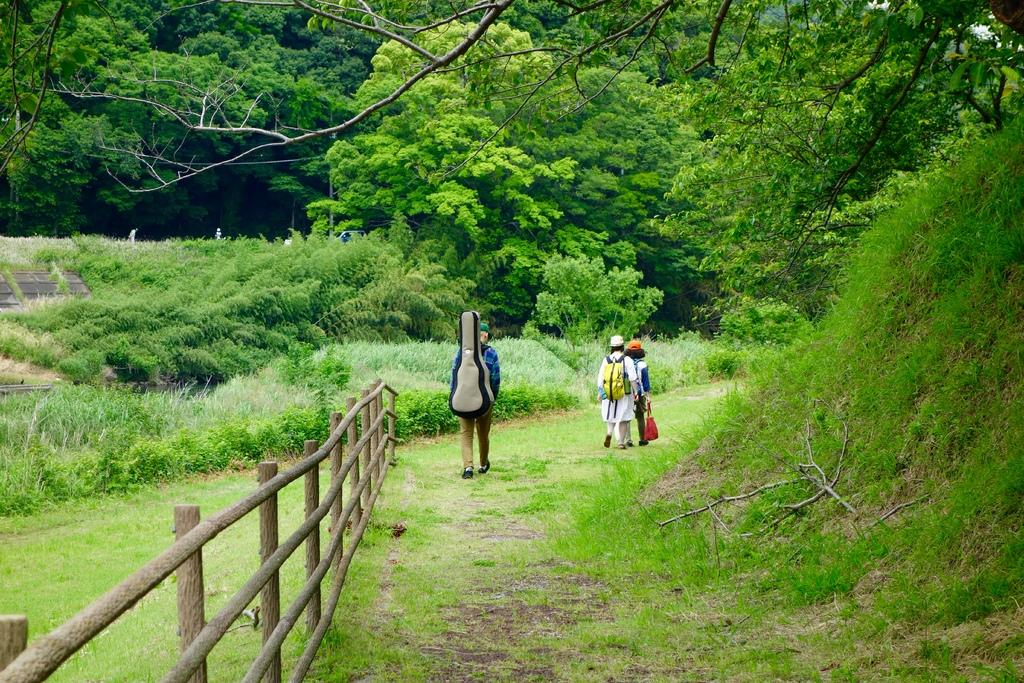What are the people in the image doing? There are persons walking in the image. What can be seen on the left side of the path? The path has a fence on the left side. What type of vegetation is present in the image? There are plants and trees in the image. What is the ground surface like in the image? The grass field is present in the image. Where are the toys placed in the image? There are no toys present in the image. Can you describe the vase on the right side of the image? There is no vase present in the image. 